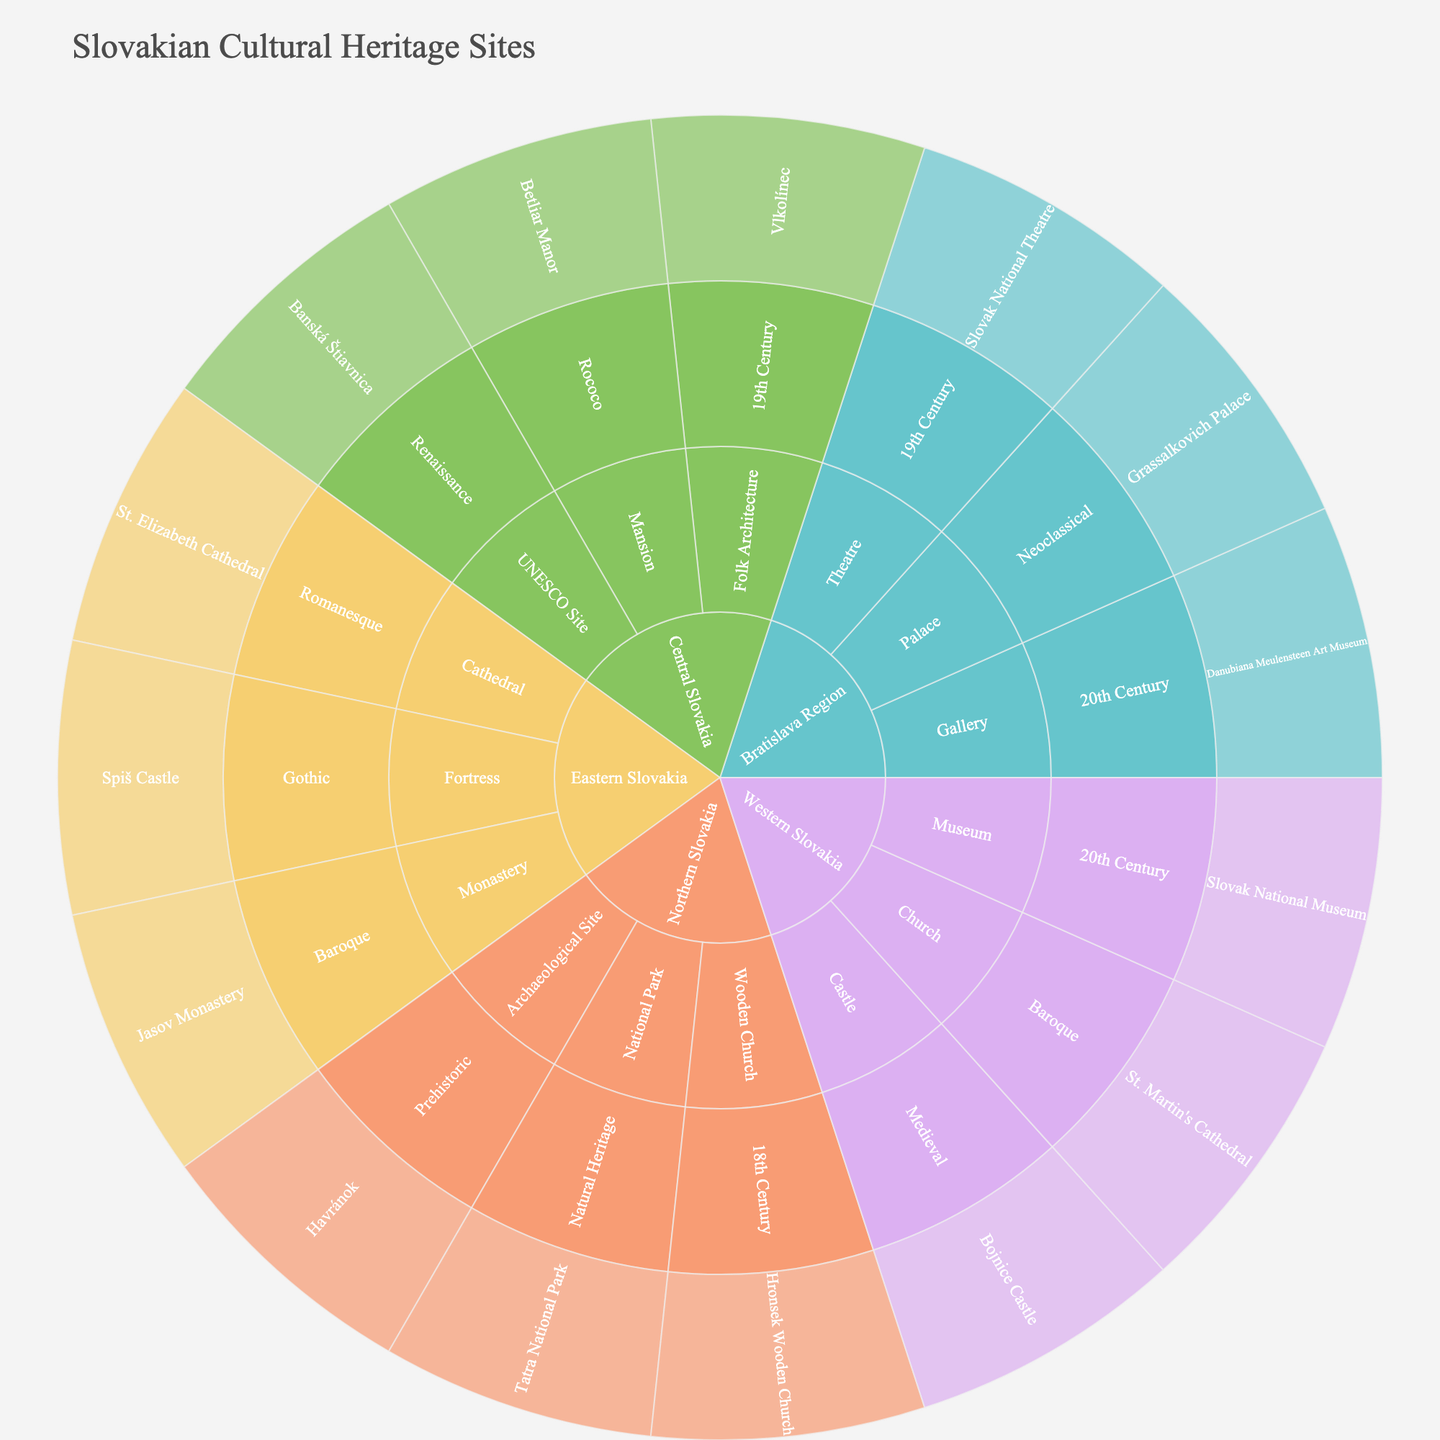What is the title of the Sunburst Plot? The title of the figure is typically displayed at the top. From the code, the title is "Slovakian Cultural Heritage Sites".
Answer: Slovakian Cultural Heritage Sites Which region has the highest number of site types? You need to count the number of unique types under each region. Western Slovakia has Castle, Church, Museum, so it is not the region with the most sites. Continue counting for other regions.
Answer: Bratislava Region Which type of site is categorized under the most historical periods? Count the number of unique historical periods for each type. Castle appears in Medieval, and so on. Continue to count for each type.
Answer: UNESCO Site How many historical periods are represented in Central Slovakia? Identify all the unique historical periods under Central Slovakia. There are Renaissance, Rococo, and 19th Century.
Answer: 3 Which site in Eastern Slovakia is categorized under the Gothic historical period? Look specifically under Eastern Slovakia for sites categorized under Gothic.
Answer: Spiš Castle Which category, Wooden Church or Folk Architecture, falls under the 19th Century historical period? Check both categories and their respective historical periods. Wooden Church is 18th Century and Folk Architecture is 19th Century.
Answer: Folk Architecture What are the different site types in the Bratislava Region? List the site types specifically under Bratislava Region: Palace, Theatre, Gallery.
Answer: Palace, Theatre, Gallery Compare the number of sites in Western Slovakia and Northern Slovakia. Which one has more? Count the total sites in Western Slovakia (3) and Northern Slovakia (3). Since both have equal sites, neither has more.
Answer: Neither What is the only Prehistoric site in the dataset? Prehistoric category is present in Northern Slovakia. The only site listed under it is Havránok.
Answer: Havránok Name a site that falls under the Baroque period in Western Slovakia. Look for sites listed under Western Slovakia and categorized as Baroque.
Answer: St. Martin's Cathedral 